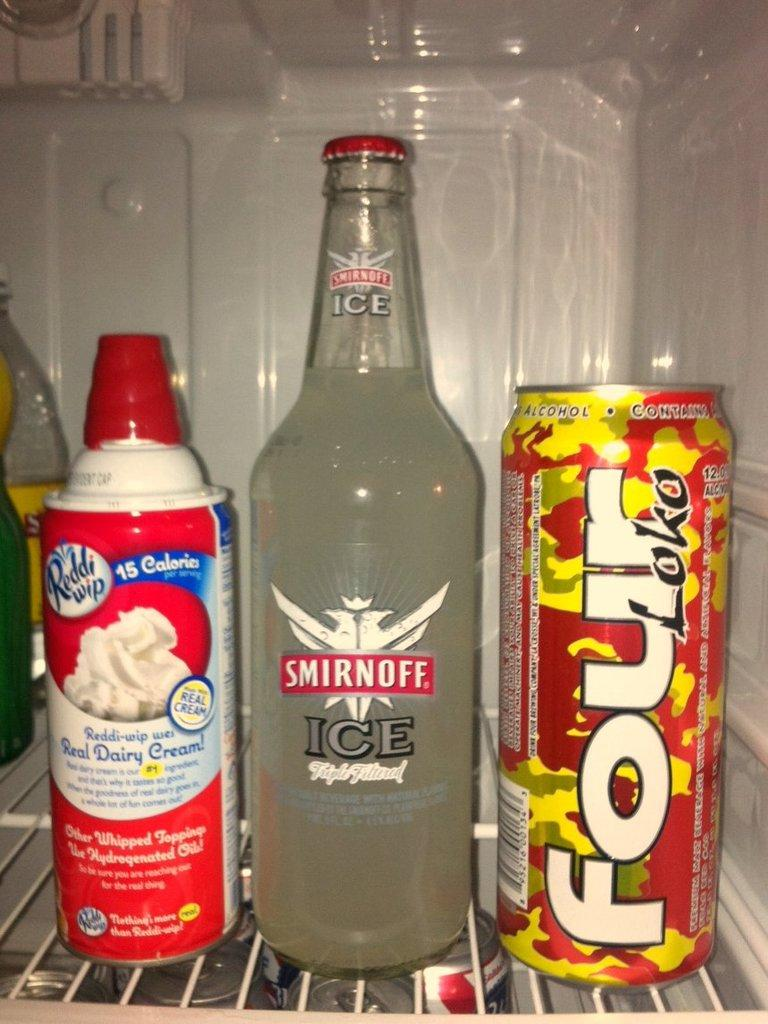<image>
Relay a brief, clear account of the picture shown. A large bottle of Smirnoff Ice in a fridge next to a can of cream. 